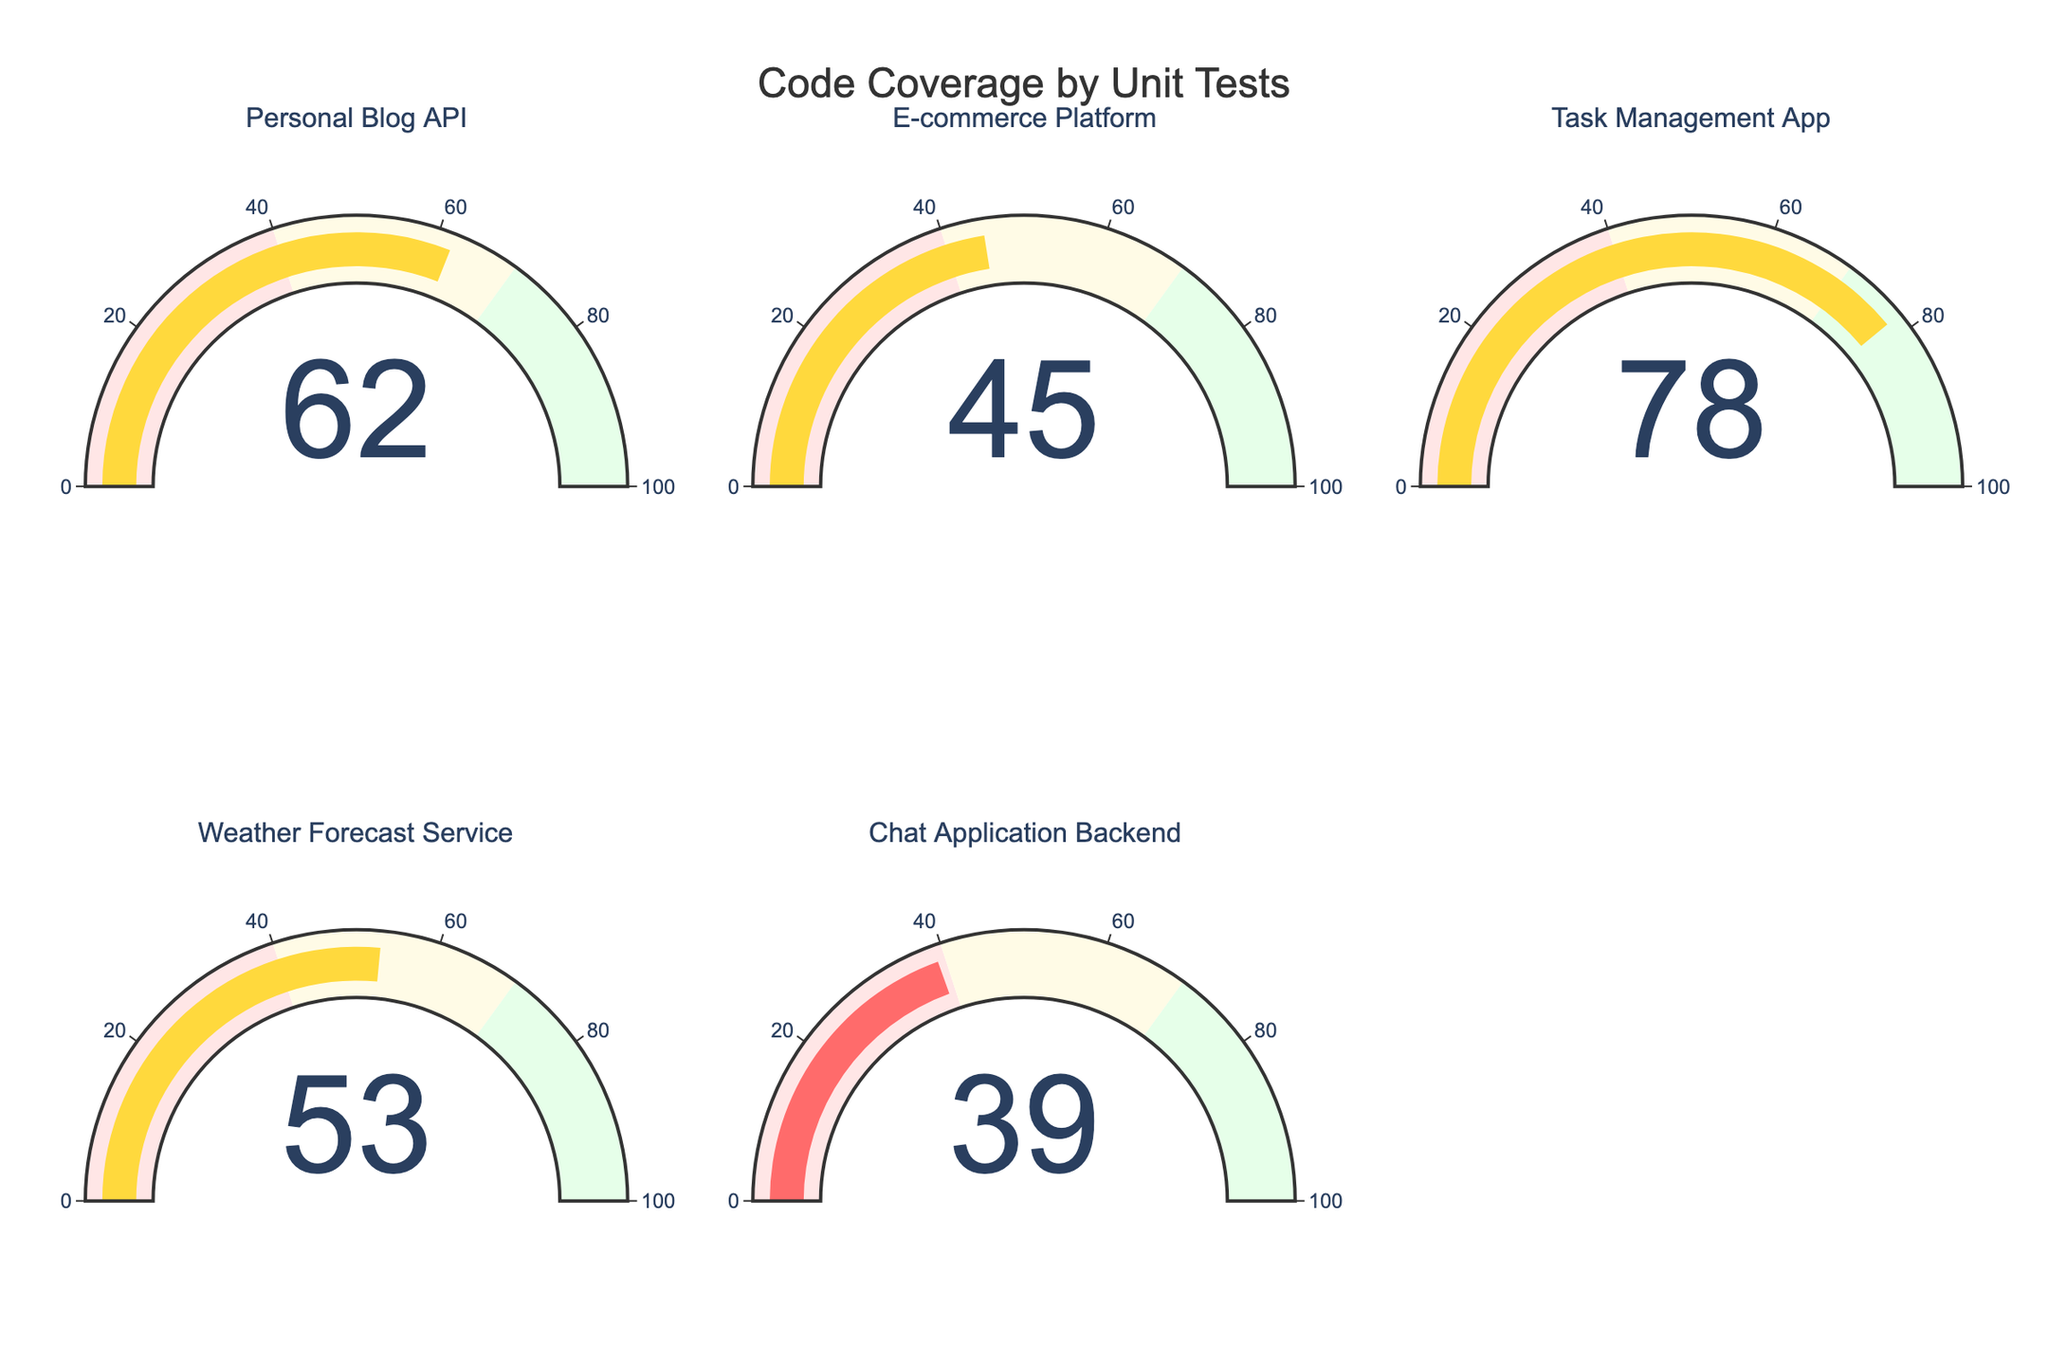Which project has the highest code coverage? Check each gauge chart to see which one has the highest value. The "Task Management App" has the highest coverage with 78%.
Answer: Task Management App What's the difference in code coverage between the E-commerce Platform and the Weather Forecast Service? The E-commerce Platform has 45% coverage, and the Weather Forecast Service has 53%. The difference is calculated as 53 - 45 = 8%.
Answer: 8% What is the average code coverage across all projects? Sum all coverage values (62 + 45 + 78 + 53 + 39) = 277. There are 5 projects, so the average is 277 / 5 = 55.4%.
Answer: 55.4% Which projects have a code coverage less than 50%? Check each gauge chart for values less than 50%. The E-commerce Platform (45%), Weather Forecast Service (53%), and Chat Application Backend (39%) are the relevant ones.
Answer: E-commerce Platform, Chat Application Backend What is the combined code coverage percentage of the Personal Blog API and the Chat Application Backend? The Personal Blog API has 62%, and the Chat Application Backend has 39%. Sum them up to get 62 + 39 = 101%.
Answer: 101% Which project falls in the yellow color range of the gauge chart? The yellow color range corresponds to code coverage values between 40% and 70%. The Personal Blog API (62%), E-commerce Platform (45%), and Weather Forecast Service (53%) fall in this range.
Answer: Personal Blog API, E-commerce Platform, Weather Forecast Service How does the coverage of the Task Management App compare with the Weather Forecast Service? The Task Management App has 78% coverage, and the Weather Forecast Service has 53%. Comparatively, the Task Management App has higher coverage.
Answer: Task Management App > Weather Forecast Service What's the total number of gauge charts displayed? Count the number of gauge charts. There are 5 gauge charts.
Answer: 5 Is there any project with code coverage exactly below the lowest green range? The lowest green range starts above 70%. The Task Management App is the only one above 70% but not exactly at 70%. Thus, no project is exactly below.
Answer: No 